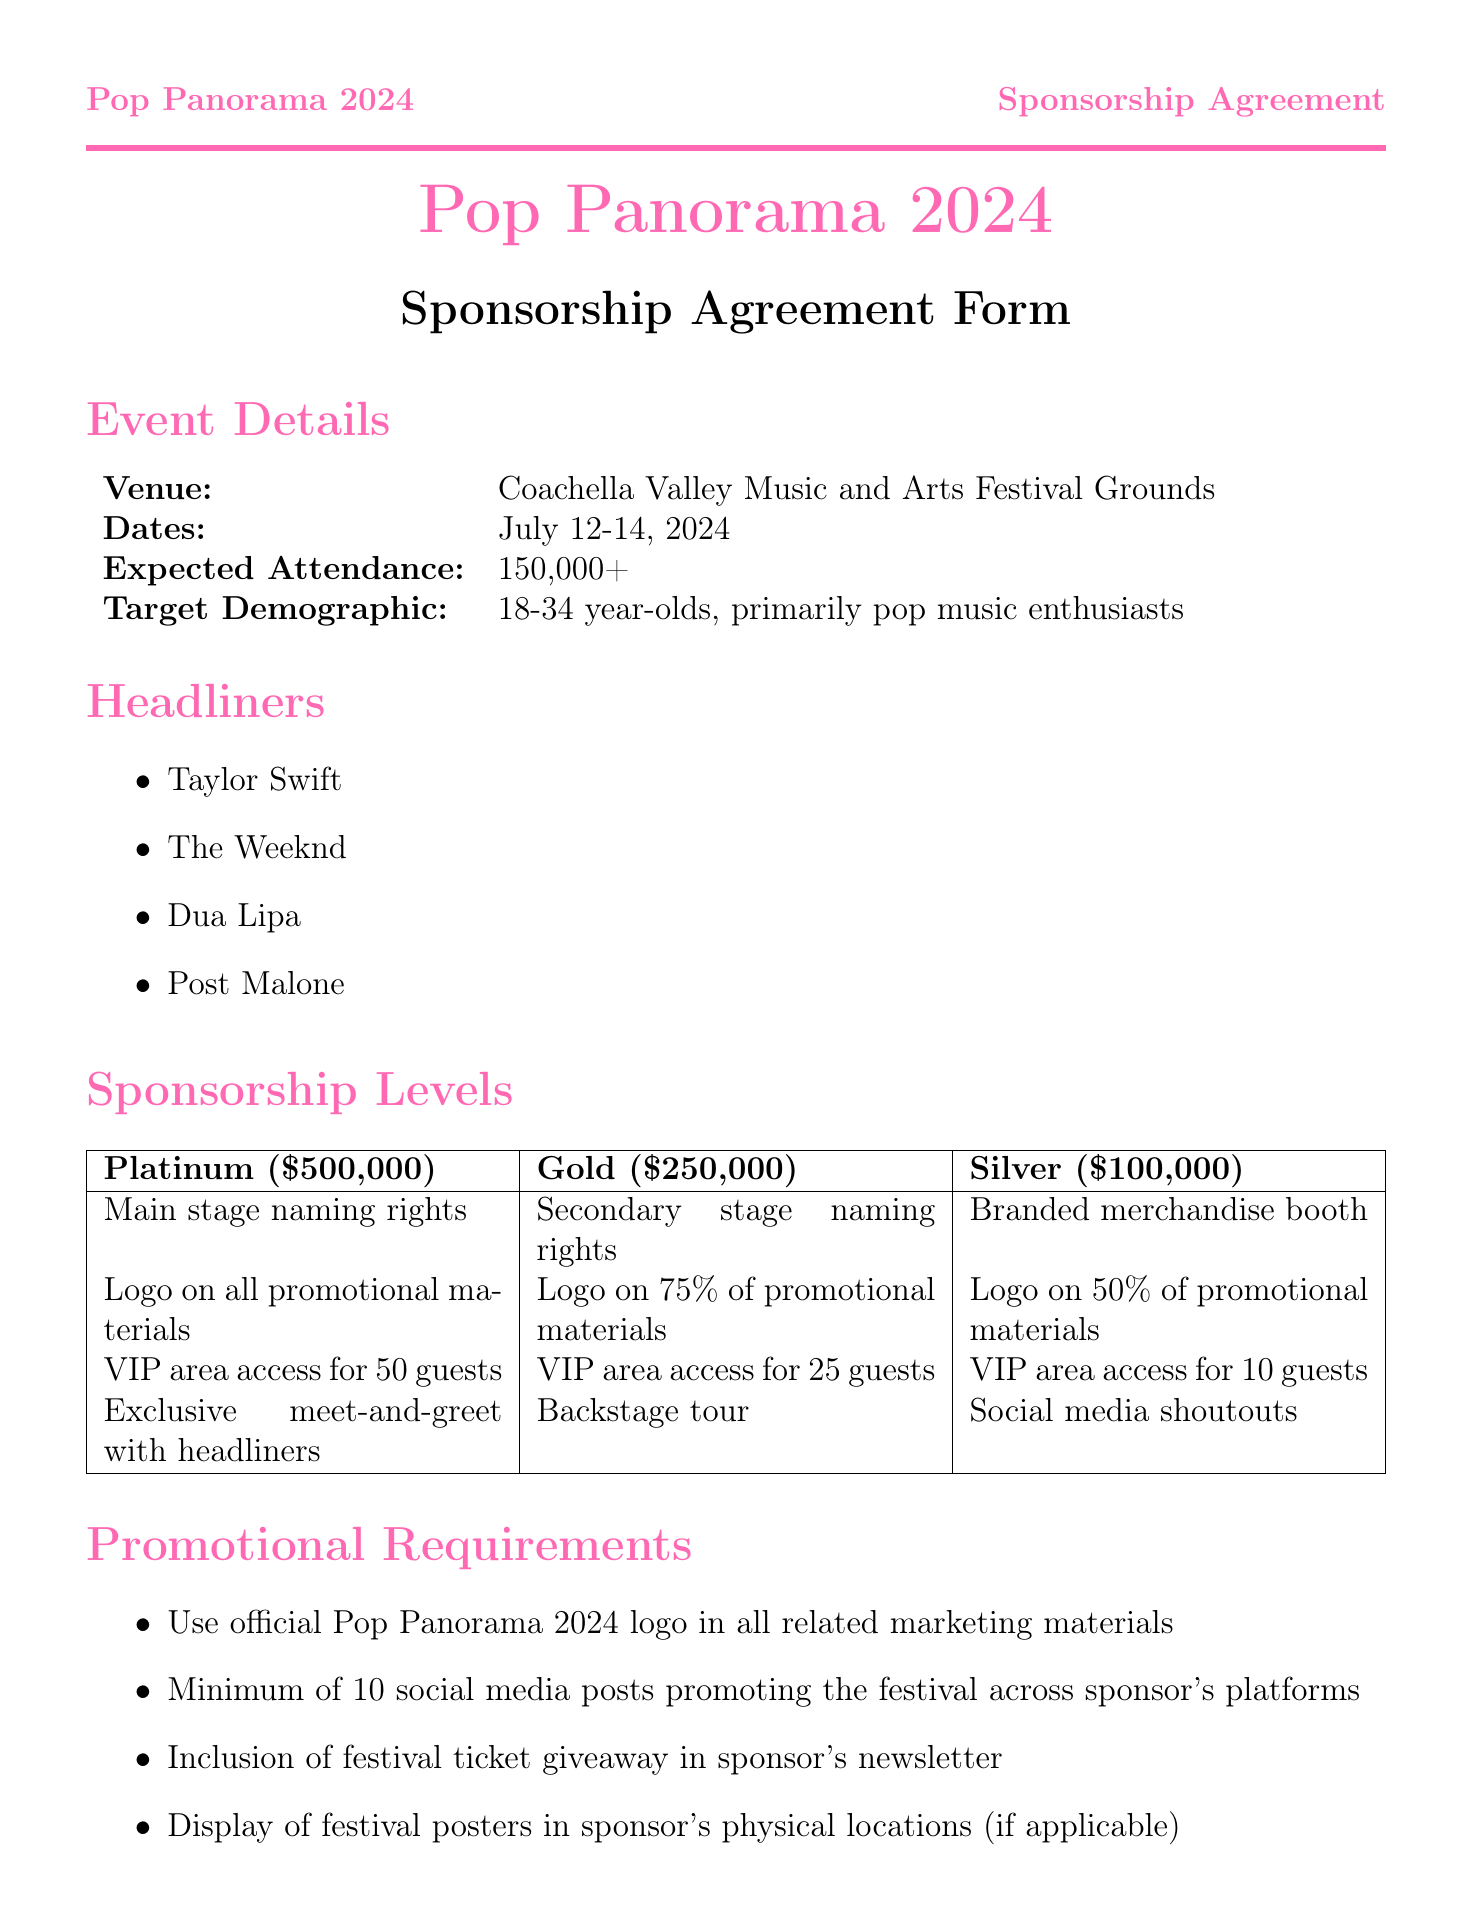What is the name of the festival? The name of the festival is stated at the beginning of the document.
Answer: Pop Panorama 2024 What are the dates of the festival? The dates are listed in the Event Details section.
Answer: July 12-14, 2024 How many guests have VIP area access at the Platinum level? The number of guests for each sponsorship level is specified in the Sponsorship Levels table.
Answer: 50 guests What is the cost of the Gold sponsorship level? The cost for each sponsorship level is provided in the Sponsorship Levels section.
Answer: $250,000 What is one of the promotional requirements for sponsors? A list of promotional requirements is outlined in the document.
Answer: Minimum of 10 social media posts What is the cancellation policy after a certain date? The cancellation policy is detailed under Payment Terms.
Answer: Non-refundable after [Date] Who are the headliners of the festival? The headliners are listed in the corresponding section.
Answer: Taylor Swift, The Weeknd, Dua Lipa, Post Malone What type of content must the vlogger create? The obligations for the vlogger are specified in the Vlogger-Specific Clauses section.
Answer: Minimum 3 sponsored content pieces What is included in the festival obligations to the sponsor? A list of festival obligations is stated in the document.
Answer: Provide sponsor with agreed-upon visibility 